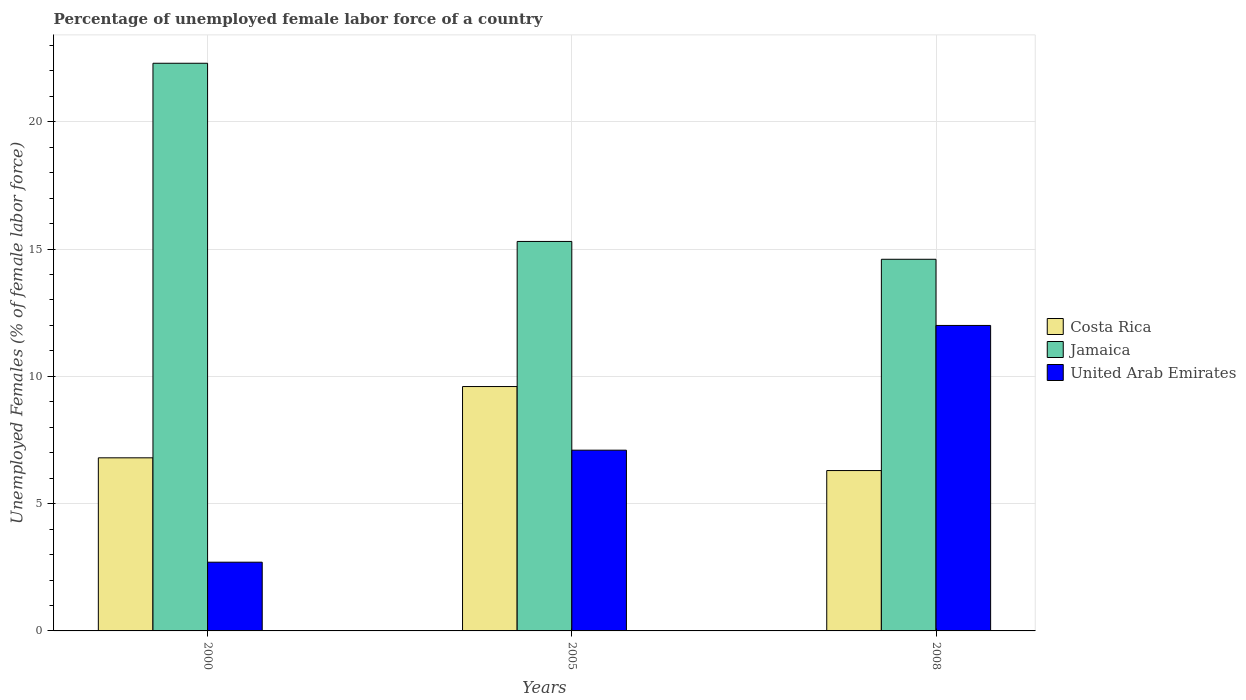What is the label of the 1st group of bars from the left?
Offer a terse response. 2000. What is the percentage of unemployed female labor force in Jamaica in 2008?
Provide a short and direct response. 14.6. Across all years, what is the maximum percentage of unemployed female labor force in Jamaica?
Keep it short and to the point. 22.3. Across all years, what is the minimum percentage of unemployed female labor force in Costa Rica?
Provide a succinct answer. 6.3. In which year was the percentage of unemployed female labor force in United Arab Emirates maximum?
Your answer should be compact. 2008. What is the total percentage of unemployed female labor force in United Arab Emirates in the graph?
Your answer should be very brief. 21.8. What is the difference between the percentage of unemployed female labor force in Jamaica in 2000 and that in 2005?
Ensure brevity in your answer.  7. What is the difference between the percentage of unemployed female labor force in United Arab Emirates in 2008 and the percentage of unemployed female labor force in Jamaica in 2005?
Ensure brevity in your answer.  -3.3. What is the average percentage of unemployed female labor force in Jamaica per year?
Your answer should be very brief. 17.4. In the year 2008, what is the difference between the percentage of unemployed female labor force in Jamaica and percentage of unemployed female labor force in Costa Rica?
Keep it short and to the point. 8.3. What is the ratio of the percentage of unemployed female labor force in Jamaica in 2000 to that in 2008?
Keep it short and to the point. 1.53. Is the difference between the percentage of unemployed female labor force in Jamaica in 2000 and 2005 greater than the difference between the percentage of unemployed female labor force in Costa Rica in 2000 and 2005?
Your response must be concise. Yes. What is the difference between the highest and the second highest percentage of unemployed female labor force in United Arab Emirates?
Your answer should be compact. 4.9. What is the difference between the highest and the lowest percentage of unemployed female labor force in Costa Rica?
Your response must be concise. 3.3. What does the 2nd bar from the left in 2008 represents?
Your response must be concise. Jamaica. What does the 1st bar from the right in 2008 represents?
Ensure brevity in your answer.  United Arab Emirates. Is it the case that in every year, the sum of the percentage of unemployed female labor force in Jamaica and percentage of unemployed female labor force in United Arab Emirates is greater than the percentage of unemployed female labor force in Costa Rica?
Offer a very short reply. Yes. Are all the bars in the graph horizontal?
Give a very brief answer. No. How many legend labels are there?
Provide a succinct answer. 3. How are the legend labels stacked?
Provide a succinct answer. Vertical. What is the title of the graph?
Offer a terse response. Percentage of unemployed female labor force of a country. Does "Nicaragua" appear as one of the legend labels in the graph?
Your answer should be very brief. No. What is the label or title of the X-axis?
Provide a succinct answer. Years. What is the label or title of the Y-axis?
Make the answer very short. Unemployed Females (% of female labor force). What is the Unemployed Females (% of female labor force) in Costa Rica in 2000?
Keep it short and to the point. 6.8. What is the Unemployed Females (% of female labor force) of Jamaica in 2000?
Keep it short and to the point. 22.3. What is the Unemployed Females (% of female labor force) in United Arab Emirates in 2000?
Provide a short and direct response. 2.7. What is the Unemployed Females (% of female labor force) of Costa Rica in 2005?
Ensure brevity in your answer.  9.6. What is the Unemployed Females (% of female labor force) of Jamaica in 2005?
Offer a terse response. 15.3. What is the Unemployed Females (% of female labor force) in United Arab Emirates in 2005?
Provide a short and direct response. 7.1. What is the Unemployed Females (% of female labor force) in Costa Rica in 2008?
Offer a very short reply. 6.3. What is the Unemployed Females (% of female labor force) of Jamaica in 2008?
Make the answer very short. 14.6. What is the Unemployed Females (% of female labor force) in United Arab Emirates in 2008?
Provide a succinct answer. 12. Across all years, what is the maximum Unemployed Females (% of female labor force) in Costa Rica?
Offer a very short reply. 9.6. Across all years, what is the maximum Unemployed Females (% of female labor force) in Jamaica?
Provide a short and direct response. 22.3. Across all years, what is the maximum Unemployed Females (% of female labor force) of United Arab Emirates?
Keep it short and to the point. 12. Across all years, what is the minimum Unemployed Females (% of female labor force) in Costa Rica?
Provide a succinct answer. 6.3. Across all years, what is the minimum Unemployed Females (% of female labor force) of Jamaica?
Ensure brevity in your answer.  14.6. Across all years, what is the minimum Unemployed Females (% of female labor force) in United Arab Emirates?
Offer a very short reply. 2.7. What is the total Unemployed Females (% of female labor force) in Costa Rica in the graph?
Ensure brevity in your answer.  22.7. What is the total Unemployed Females (% of female labor force) in Jamaica in the graph?
Ensure brevity in your answer.  52.2. What is the total Unemployed Females (% of female labor force) of United Arab Emirates in the graph?
Provide a short and direct response. 21.8. What is the difference between the Unemployed Females (% of female labor force) in Jamaica in 2000 and that in 2005?
Your answer should be very brief. 7. What is the difference between the Unemployed Females (% of female labor force) of Costa Rica in 2000 and that in 2008?
Make the answer very short. 0.5. What is the difference between the Unemployed Females (% of female labor force) of United Arab Emirates in 2000 and that in 2008?
Offer a terse response. -9.3. What is the difference between the Unemployed Females (% of female labor force) of Costa Rica in 2005 and that in 2008?
Your answer should be very brief. 3.3. What is the difference between the Unemployed Females (% of female labor force) in United Arab Emirates in 2005 and that in 2008?
Give a very brief answer. -4.9. What is the difference between the Unemployed Females (% of female labor force) in Costa Rica in 2000 and the Unemployed Females (% of female labor force) in United Arab Emirates in 2005?
Your answer should be very brief. -0.3. What is the difference between the Unemployed Females (% of female labor force) in Jamaica in 2005 and the Unemployed Females (% of female labor force) in United Arab Emirates in 2008?
Your answer should be compact. 3.3. What is the average Unemployed Females (% of female labor force) of Costa Rica per year?
Give a very brief answer. 7.57. What is the average Unemployed Females (% of female labor force) in Jamaica per year?
Ensure brevity in your answer.  17.4. What is the average Unemployed Females (% of female labor force) in United Arab Emirates per year?
Give a very brief answer. 7.27. In the year 2000, what is the difference between the Unemployed Females (% of female labor force) of Costa Rica and Unemployed Females (% of female labor force) of Jamaica?
Provide a short and direct response. -15.5. In the year 2000, what is the difference between the Unemployed Females (% of female labor force) in Jamaica and Unemployed Females (% of female labor force) in United Arab Emirates?
Your answer should be very brief. 19.6. In the year 2005, what is the difference between the Unemployed Females (% of female labor force) in Costa Rica and Unemployed Females (% of female labor force) in Jamaica?
Your answer should be compact. -5.7. In the year 2005, what is the difference between the Unemployed Females (% of female labor force) in Costa Rica and Unemployed Females (% of female labor force) in United Arab Emirates?
Keep it short and to the point. 2.5. In the year 2008, what is the difference between the Unemployed Females (% of female labor force) in Costa Rica and Unemployed Females (% of female labor force) in Jamaica?
Give a very brief answer. -8.3. In the year 2008, what is the difference between the Unemployed Females (% of female labor force) in Costa Rica and Unemployed Females (% of female labor force) in United Arab Emirates?
Provide a succinct answer. -5.7. What is the ratio of the Unemployed Females (% of female labor force) in Costa Rica in 2000 to that in 2005?
Make the answer very short. 0.71. What is the ratio of the Unemployed Females (% of female labor force) of Jamaica in 2000 to that in 2005?
Provide a short and direct response. 1.46. What is the ratio of the Unemployed Females (% of female labor force) of United Arab Emirates in 2000 to that in 2005?
Offer a terse response. 0.38. What is the ratio of the Unemployed Females (% of female labor force) of Costa Rica in 2000 to that in 2008?
Your response must be concise. 1.08. What is the ratio of the Unemployed Females (% of female labor force) of Jamaica in 2000 to that in 2008?
Keep it short and to the point. 1.53. What is the ratio of the Unemployed Females (% of female labor force) of United Arab Emirates in 2000 to that in 2008?
Ensure brevity in your answer.  0.23. What is the ratio of the Unemployed Females (% of female labor force) of Costa Rica in 2005 to that in 2008?
Your answer should be very brief. 1.52. What is the ratio of the Unemployed Females (% of female labor force) of Jamaica in 2005 to that in 2008?
Offer a terse response. 1.05. What is the ratio of the Unemployed Females (% of female labor force) in United Arab Emirates in 2005 to that in 2008?
Provide a short and direct response. 0.59. What is the difference between the highest and the second highest Unemployed Females (% of female labor force) in Costa Rica?
Give a very brief answer. 2.8. What is the difference between the highest and the second highest Unemployed Females (% of female labor force) in Jamaica?
Your response must be concise. 7. What is the difference between the highest and the lowest Unemployed Females (% of female labor force) in Costa Rica?
Offer a terse response. 3.3. What is the difference between the highest and the lowest Unemployed Females (% of female labor force) of Jamaica?
Provide a short and direct response. 7.7. What is the difference between the highest and the lowest Unemployed Females (% of female labor force) of United Arab Emirates?
Give a very brief answer. 9.3. 